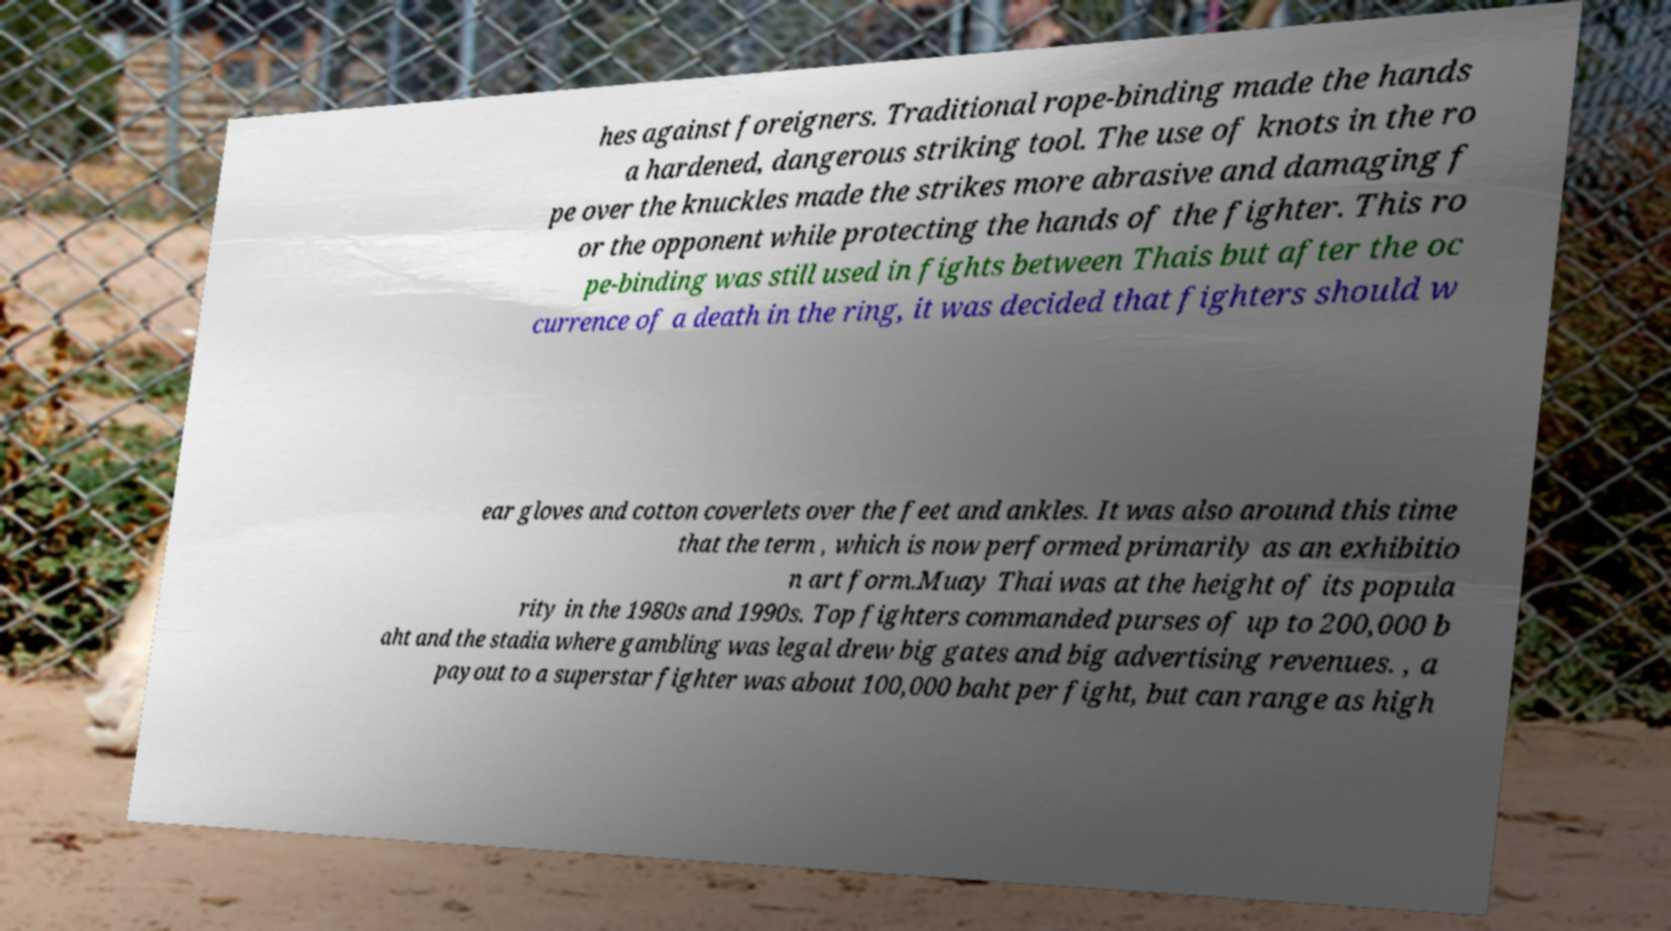Could you extract and type out the text from this image? hes against foreigners. Traditional rope-binding made the hands a hardened, dangerous striking tool. The use of knots in the ro pe over the knuckles made the strikes more abrasive and damaging f or the opponent while protecting the hands of the fighter. This ro pe-binding was still used in fights between Thais but after the oc currence of a death in the ring, it was decided that fighters should w ear gloves and cotton coverlets over the feet and ankles. It was also around this time that the term , which is now performed primarily as an exhibitio n art form.Muay Thai was at the height of its popula rity in the 1980s and 1990s. Top fighters commanded purses of up to 200,000 b aht and the stadia where gambling was legal drew big gates and big advertising revenues. , a payout to a superstar fighter was about 100,000 baht per fight, but can range as high 